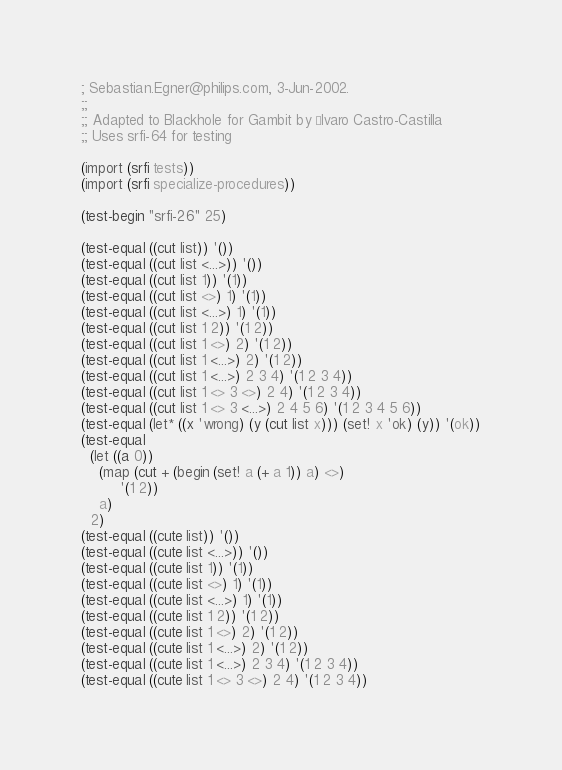Convert code to text. <code><loc_0><loc_0><loc_500><loc_500><_Scheme_>; Sebastian.Egner@philips.com, 3-Jun-2002.
;; 
;; Adapted to Blackhole for Gambit by Álvaro Castro-Castilla
;; Uses srfi-64 for testing

(import (srfi tests))
(import (srfi specialize-procedures))

(test-begin "srfi-26" 25)

(test-equal ((cut list)) '())
(test-equal ((cut list <...>)) '())
(test-equal ((cut list 1)) '(1))
(test-equal ((cut list <>) 1) '(1))
(test-equal ((cut list <...>) 1) '(1))
(test-equal ((cut list 1 2)) '(1 2))
(test-equal ((cut list 1 <>) 2) '(1 2))
(test-equal ((cut list 1 <...>) 2) '(1 2))
(test-equal ((cut list 1 <...>) 2 3 4) '(1 2 3 4))
(test-equal ((cut list 1 <> 3 <>) 2 4) '(1 2 3 4))
(test-equal ((cut list 1 <> 3 <...>) 2 4 5 6) '(1 2 3 4 5 6))
(test-equal (let* ((x 'wrong) (y (cut list x))) (set! x 'ok) (y)) '(ok))
(test-equal 
  (let ((a 0))
    (map (cut + (begin (set! a (+ a 1)) a) <>)
         '(1 2))
    a)
  2)
(test-equal ((cute list)) '())
(test-equal ((cute list <...>)) '())
(test-equal ((cute list 1)) '(1))
(test-equal ((cute list <>) 1) '(1))
(test-equal ((cute list <...>) 1) '(1))
(test-equal ((cute list 1 2)) '(1 2))
(test-equal ((cute list 1 <>) 2) '(1 2))
(test-equal ((cute list 1 <...>) 2) '(1 2))
(test-equal ((cute list 1 <...>) 2 3 4) '(1 2 3 4))
(test-equal ((cute list 1 <> 3 <>) 2 4) '(1 2 3 4))</code> 